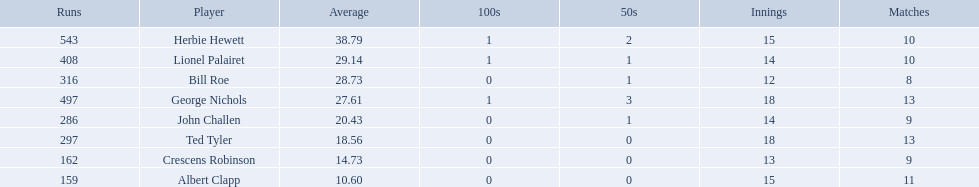Who are all of the players? Herbie Hewett, Lionel Palairet, Bill Roe, George Nichols, John Challen, Ted Tyler, Crescens Robinson, Albert Clapp. How many innings did they play in? 15, 14, 12, 18, 14, 18, 13, 15. Which player was in fewer than 13 innings? Bill Roe. 